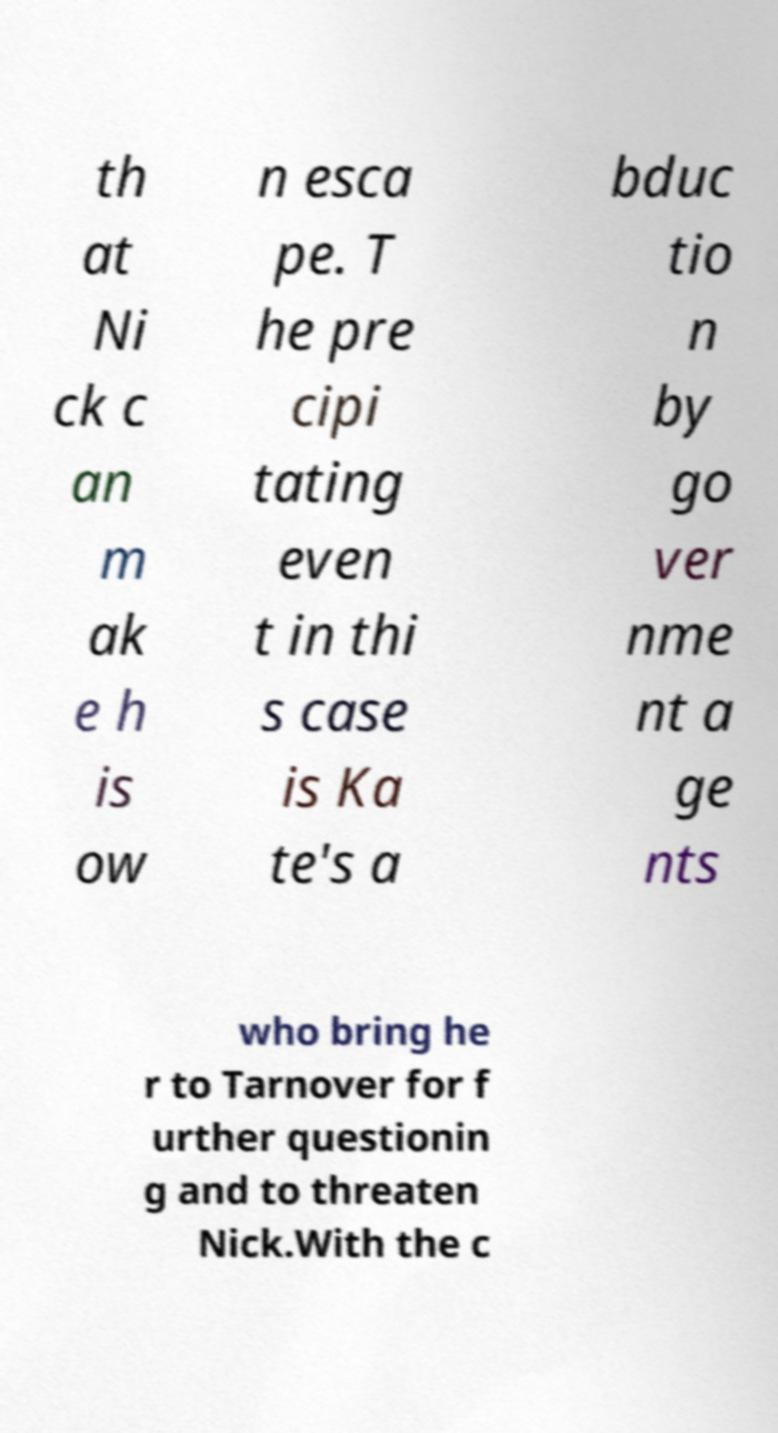For documentation purposes, I need the text within this image transcribed. Could you provide that? th at Ni ck c an m ak e h is ow n esca pe. T he pre cipi tating even t in thi s case is Ka te's a bduc tio n by go ver nme nt a ge nts who bring he r to Tarnover for f urther questionin g and to threaten Nick.With the c 